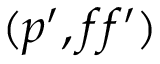<formula> <loc_0><loc_0><loc_500><loc_500>( p ^ { \prime } , f f ^ { \prime } )</formula> 